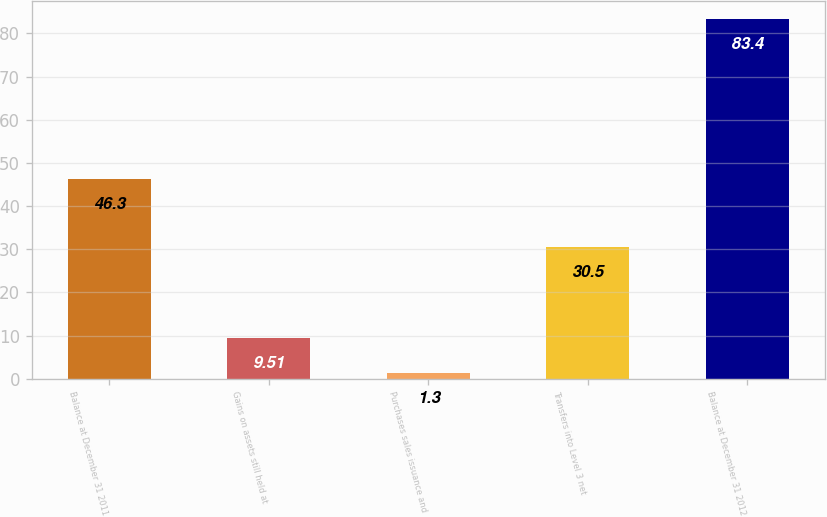Convert chart to OTSL. <chart><loc_0><loc_0><loc_500><loc_500><bar_chart><fcel>Balance at December 31 2011<fcel>Gains on assets still held at<fcel>Purchases sales issuance and<fcel>Transfers into Level 3 net<fcel>Balance at December 31 2012<nl><fcel>46.3<fcel>9.51<fcel>1.3<fcel>30.5<fcel>83.4<nl></chart> 